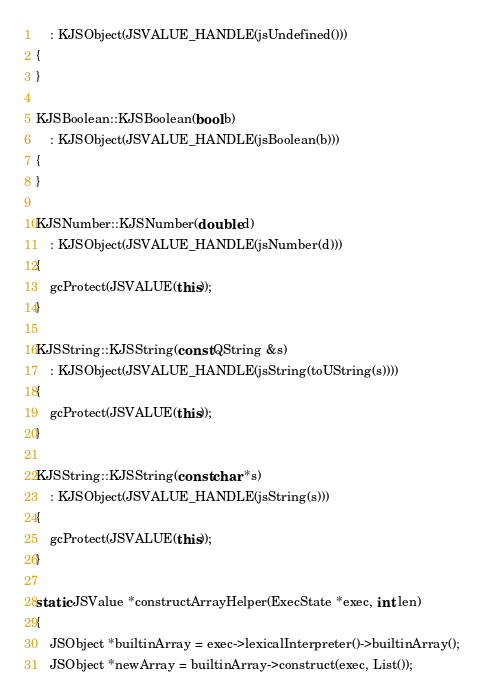<code> <loc_0><loc_0><loc_500><loc_500><_C++_>    : KJSObject(JSVALUE_HANDLE(jsUndefined()))
{
}

KJSBoolean::KJSBoolean(bool b)
    : KJSObject(JSVALUE_HANDLE(jsBoolean(b)))
{
}

KJSNumber::KJSNumber(double d)
    : KJSObject(JSVALUE_HANDLE(jsNumber(d)))
{
    gcProtect(JSVALUE(this));
}

KJSString::KJSString(const QString &s)
    : KJSObject(JSVALUE_HANDLE(jsString(toUString(s))))
{
    gcProtect(JSVALUE(this));
}

KJSString::KJSString(const char *s)
    : KJSObject(JSVALUE_HANDLE(jsString(s)))
{
    gcProtect(JSVALUE(this));
}

static JSValue *constructArrayHelper(ExecState *exec, int len)
{
    JSObject *builtinArray = exec->lexicalInterpreter()->builtinArray();
    JSObject *newArray = builtinArray->construct(exec, List());</code> 